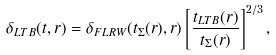Convert formula to latex. <formula><loc_0><loc_0><loc_500><loc_500>\delta _ { L T B } ( t , r ) = \delta _ { F L R W } ( t _ { \Sigma } ( r ) , r ) \left [ \frac { t _ { L T B } ( r ) } { t _ { \Sigma } ( r ) } \right ] ^ { 2 / 3 } ,</formula> 